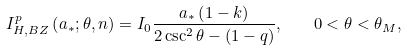<formula> <loc_0><loc_0><loc_500><loc_500>I _ { H , B Z } ^ { p } \left ( { a _ { * } ; \theta , n } \right ) = I _ { 0 } \frac { a _ { * } \left ( { 1 - k } \right ) } { 2 \csc ^ { 2 } \theta - \left ( { 1 - q } \right ) } , \quad 0 < \theta < \theta _ { M } ,</formula> 